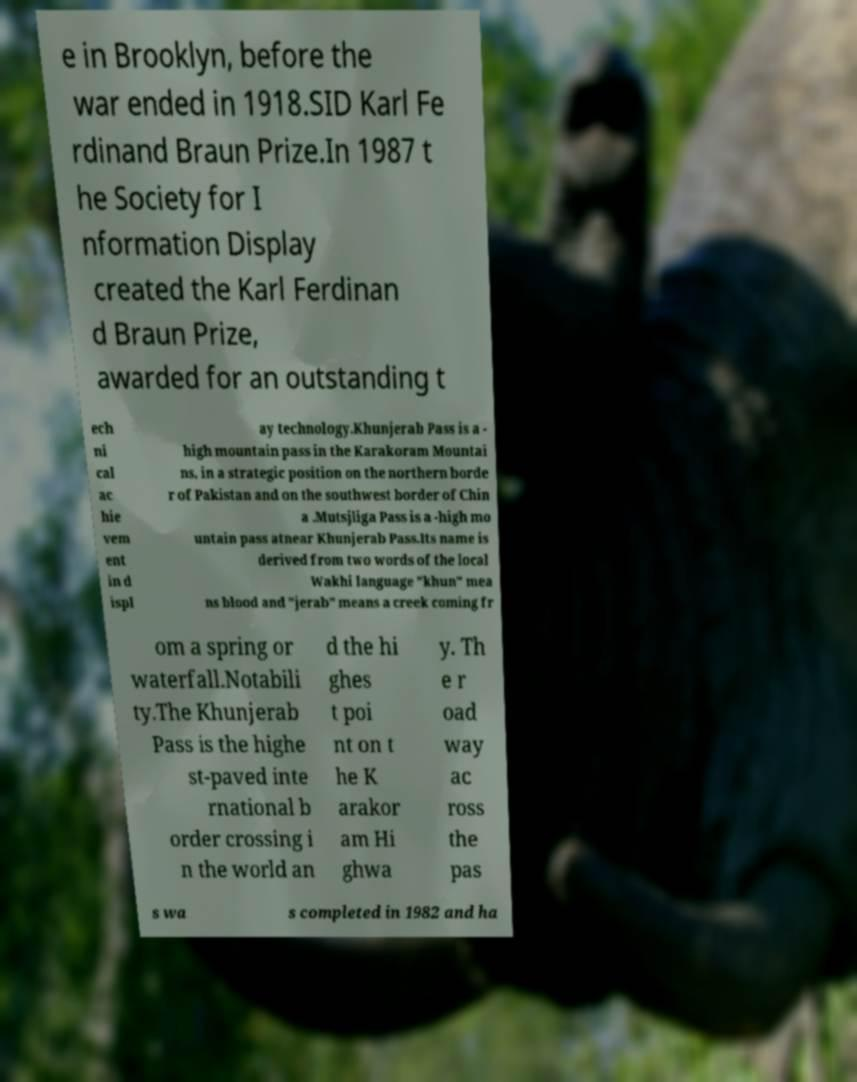I need the written content from this picture converted into text. Can you do that? e in Brooklyn, before the war ended in 1918.SID Karl Fe rdinand Braun Prize.In 1987 t he Society for I nformation Display created the Karl Ferdinan d Braun Prize, awarded for an outstanding t ech ni cal ac hie vem ent in d ispl ay technology.Khunjerab Pass is a - high mountain pass in the Karakoram Mountai ns, in a strategic position on the northern borde r of Pakistan and on the southwest border of Chin a .Mutsjliga Pass is a -high mo untain pass atnear Khunjerab Pass.Its name is derived from two words of the local Wakhi language "khun" mea ns blood and "jerab" means a creek coming fr om a spring or waterfall.Notabili ty.The Khunjerab Pass is the highe st-paved inte rnational b order crossing i n the world an d the hi ghes t poi nt on t he K arakor am Hi ghwa y. Th e r oad way ac ross the pas s wa s completed in 1982 and ha 